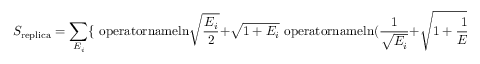<formula> <loc_0><loc_0><loc_500><loc_500>S _ { r e p l i c a } = \sum _ { E _ { i } } \{ \ o p e r a t o r n a m e { \ln } \sqrt { { \frac { E _ { i } } { 2 } } } + \sqrt { 1 + E _ { i } } \ o p e r a t o r n a m e { \ln } ( { \frac { 1 } { \sqrt { E _ { i } } } } + \sqrt { 1 + { \frac { 1 } { E _ { i } } } } ) \}</formula> 